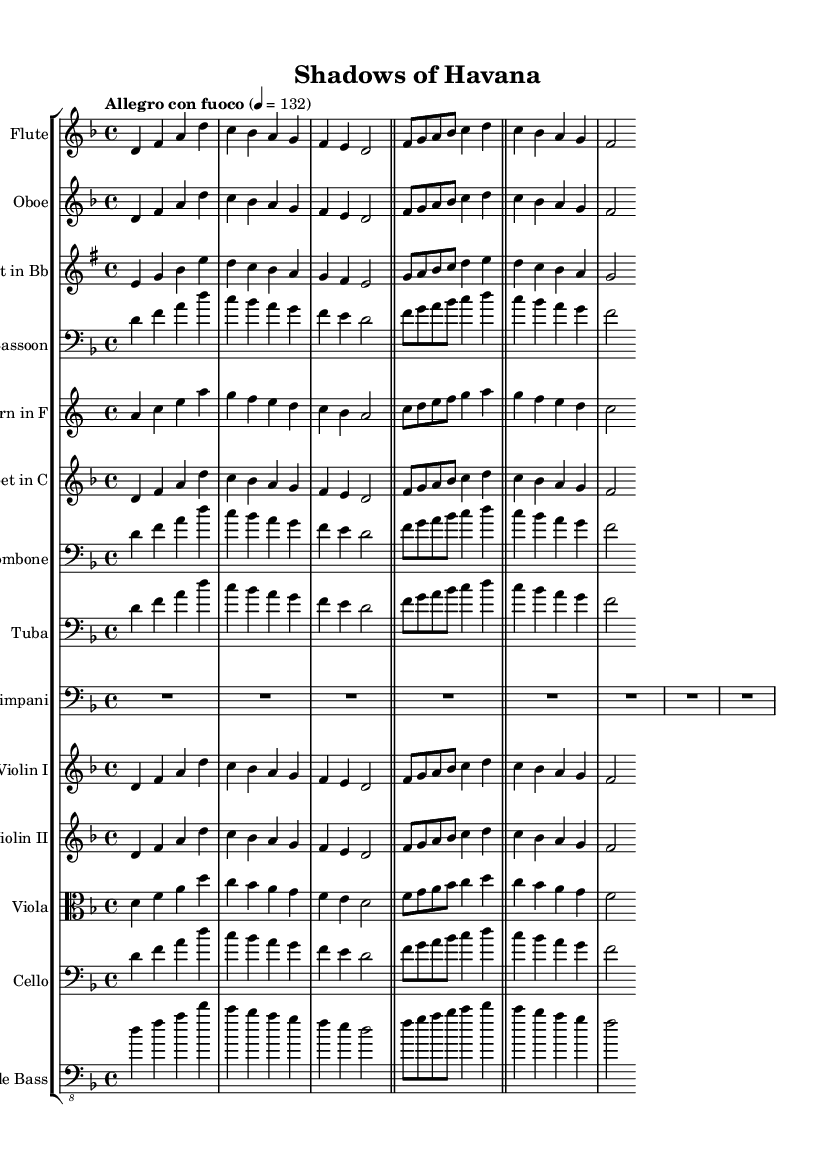What is the key signature of this symphony? The key signature is indicated as D minor, which is shown by the presence of one flat (B♭).
Answer: D minor What is the time signature for the music? The time signature is represented as 4/4, meaning there are four beats in each measure and a quarter note gets one beat.
Answer: 4/4 What is the tempo marking for this piece? The tempo marking is stated as "Allegro con fuoco", indicating a fast and fiery pace for the performance.
Answer: Allegro con fuoco Which instrument has the main theme presented first? The Flute is the first instrument to present the main theme in the symphony.
Answer: Flute How many total measures are in the main theme of the music? The main theme consists of 8 measures, as it begins and ends distinctly before transitioning to the secondary theme.
Answer: 8 What instruments play the secondary theme? The secondary theme is played by the Flute, Oboe, Clarinet, Horn, and Violin I, which are clearly indicated on their respective staves following the initial theme.
Answer: Flute, Oboe, Clarinet, Horn, Violin I Why might D minor have been chosen for the symphony considering its themes? D minor is often associated with seriousness and intensity, which aligns with the dramatic subject matter of the Cuban Missile Crisis and covert operations, enhancing the emotional impact of the music.
Answer: Seriousness and intensity 